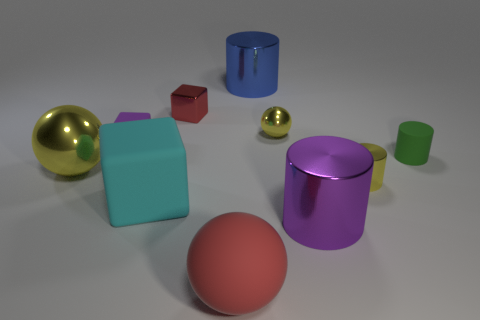Subtract 1 cylinders. How many cylinders are left? 3 Subtract all balls. How many objects are left? 7 Add 5 gray rubber blocks. How many gray rubber blocks exist? 5 Subtract 0 cyan cylinders. How many objects are left? 10 Subtract all large cyan matte balls. Subtract all large blue things. How many objects are left? 9 Add 4 large purple metal things. How many large purple metal things are left? 5 